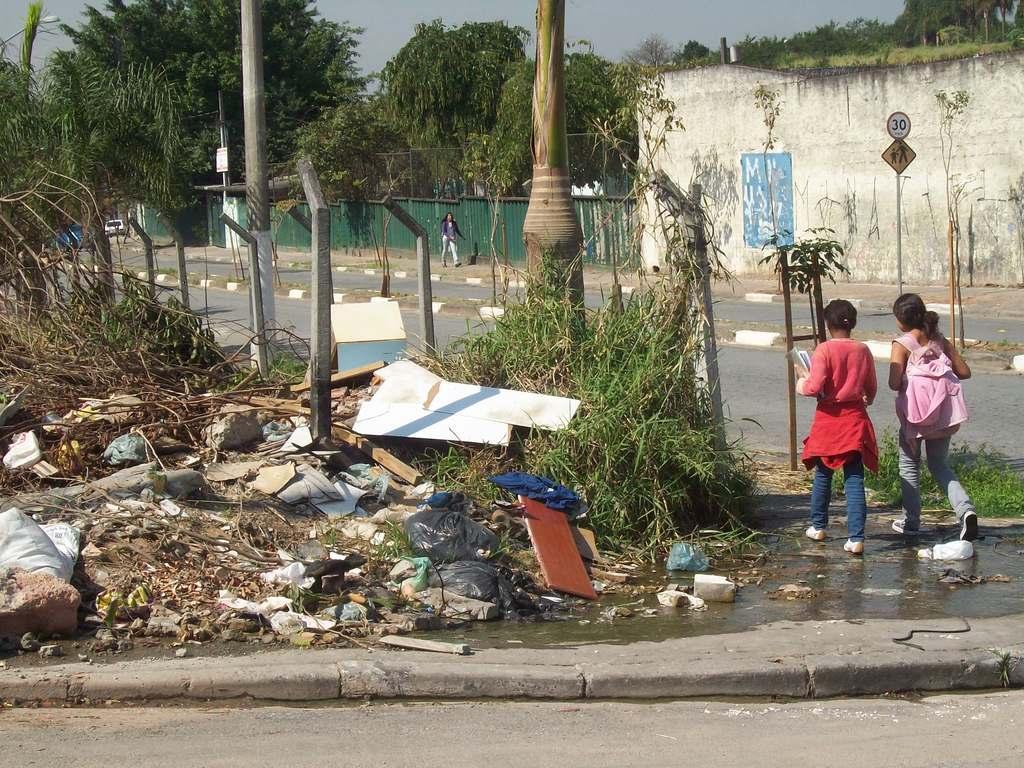Could you give a brief overview of what you see in this image? In this image I can see two people with different color dresses. To the left I can see the grass, wooden objects, plastic covers, clothes and many rocks can be seen. In the background I can see the vehicle on the road. To the side of the road I can see poles, boards, one more person, wall and many trees. I can also see the sky in the back. 